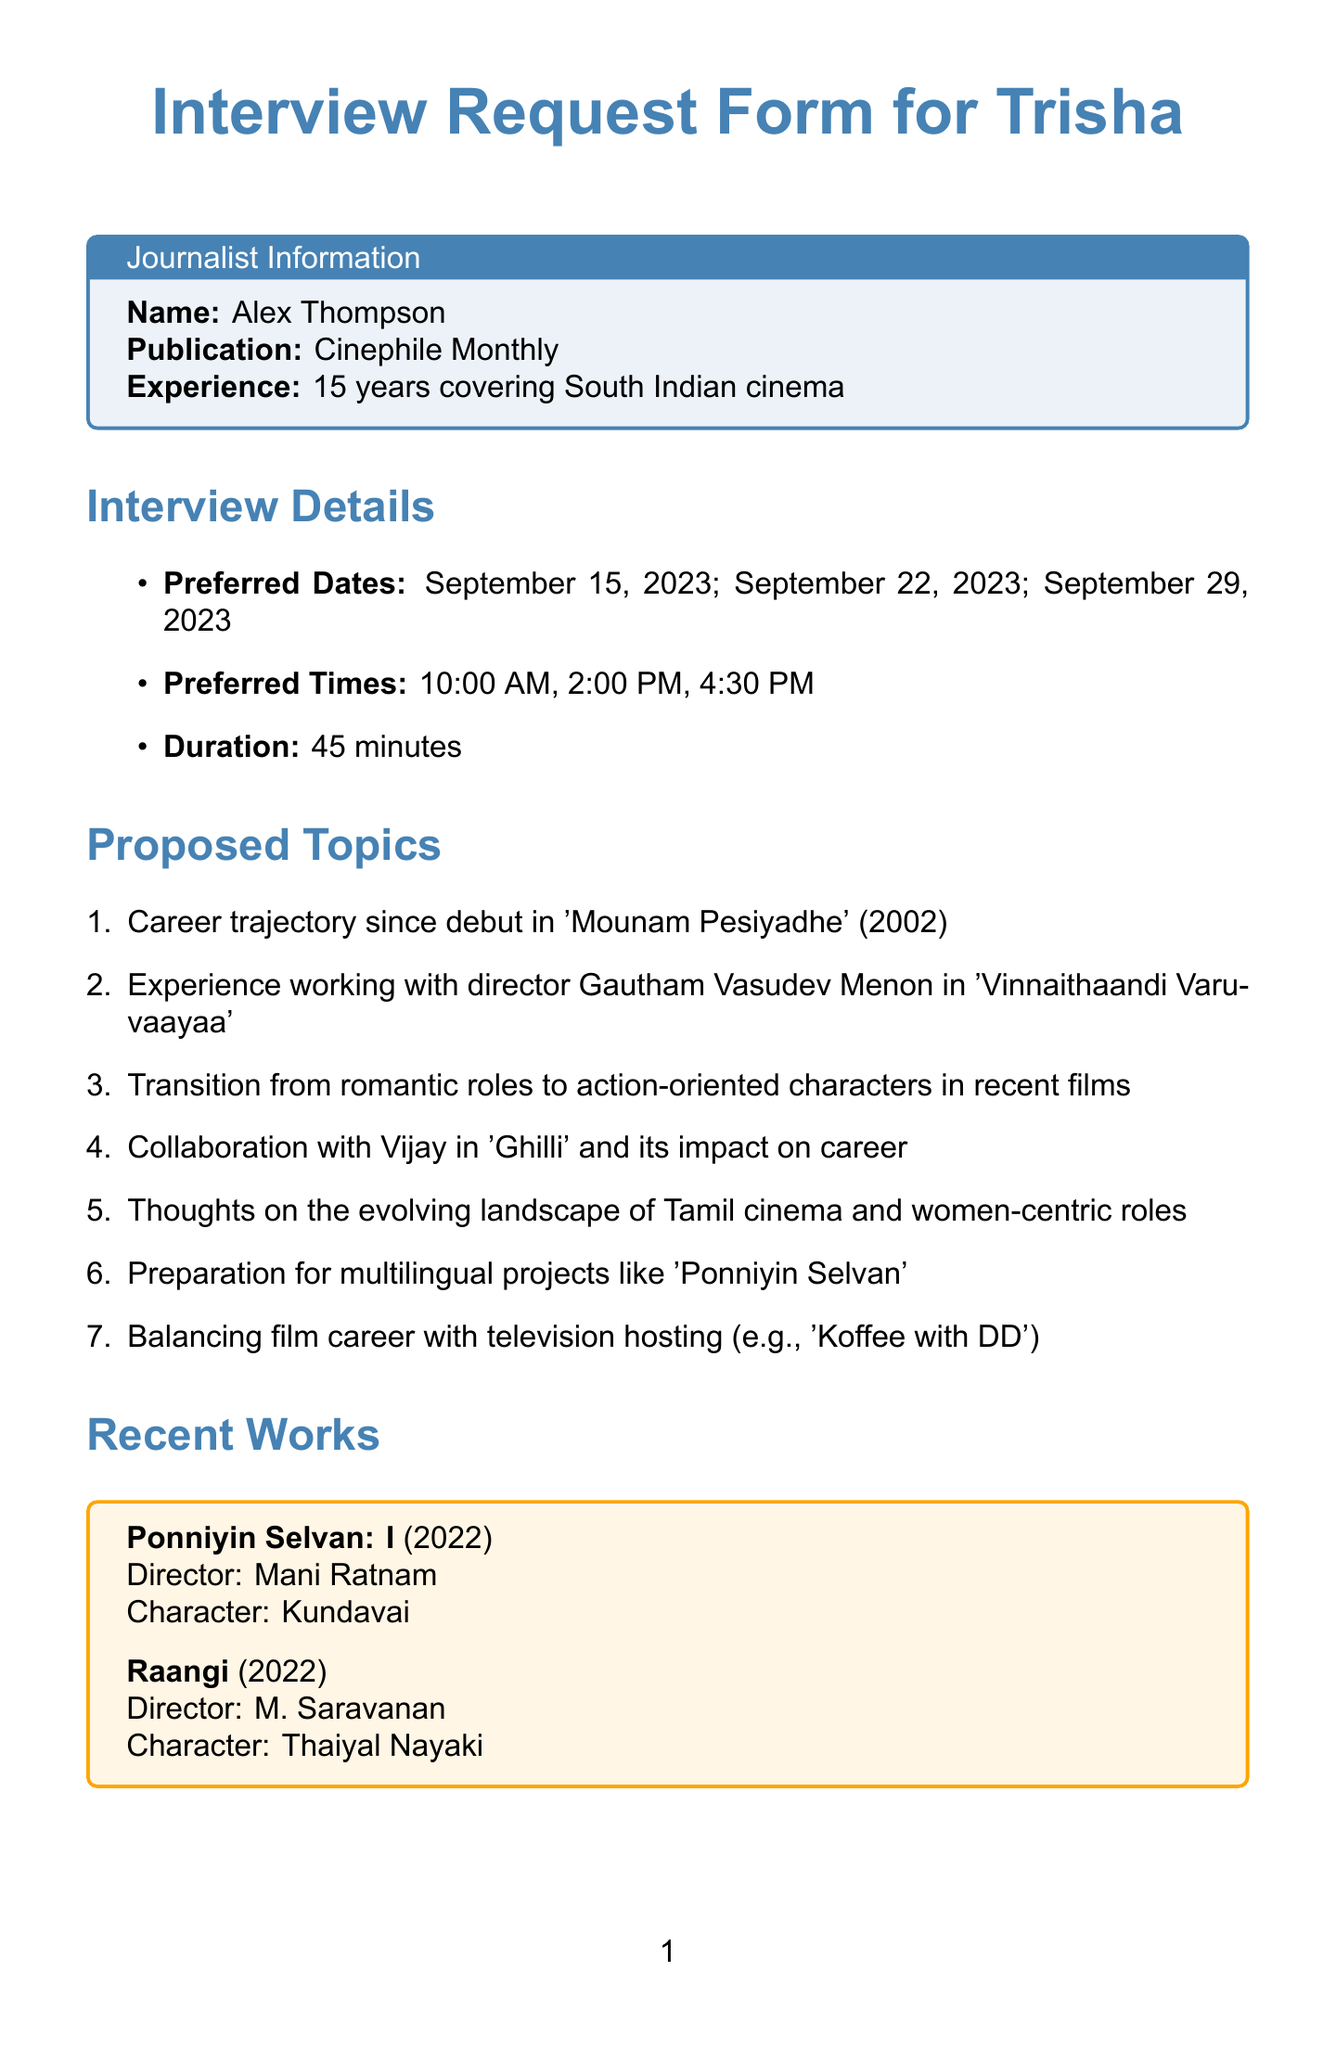What is the title of the document? The document is titled "Interview Request Form for Trisha" as stated at the top of the rendered document.
Answer: Interview Request Form for Trisha Who is the journalist requesting the interview? The name of the journalist requesting the interview is mentioned in the journalist information section.
Answer: Alex Thompson What is the publication associated with the journalist? The publication is listed alongside the journalist's name in the document.
Answer: Cinephile Monthly What are the preferred dates for the interview? The preferred dates are listed in the interview details section; each date is clearly mentioned.
Answer: September 15, 2023; September 22, 2023; September 29, 2023 How long is the proposed duration of the interview? The duration of the interview is specified in the interview details section.
Answer: 45 minutes Which character does Trisha play in "Ponniyin Selvan: I"? The character's name is indicated in the recent works section of the document.
Answer: Kundavai What is the exclusivity period requested by the journalist? The exclusivity period is mentioned in the special requests section of the document.
Answer: 48 hours What is the publicist's email address? The email address of the publicist is provided in the contact information section.
Answer: suresh.kumar@trishapr.com What topics are proposed for discussion during the interview? The proposed topics for discussion are listed in the respective section of the document.
Answer: Career trajectory, experience with director Gautham Vasudev Menon, etc 